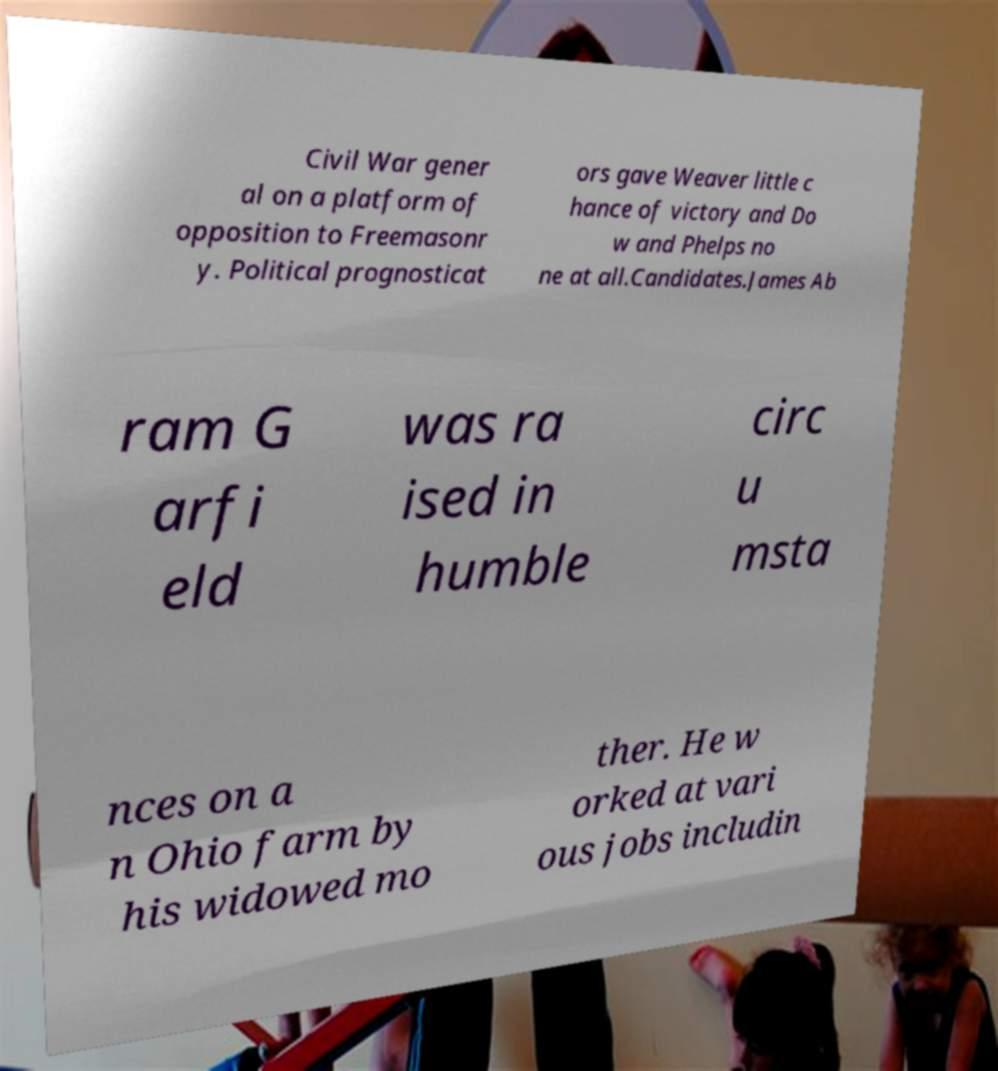There's text embedded in this image that I need extracted. Can you transcribe it verbatim? Civil War gener al on a platform of opposition to Freemasonr y. Political prognosticat ors gave Weaver little c hance of victory and Do w and Phelps no ne at all.Candidates.James Ab ram G arfi eld was ra ised in humble circ u msta nces on a n Ohio farm by his widowed mo ther. He w orked at vari ous jobs includin 